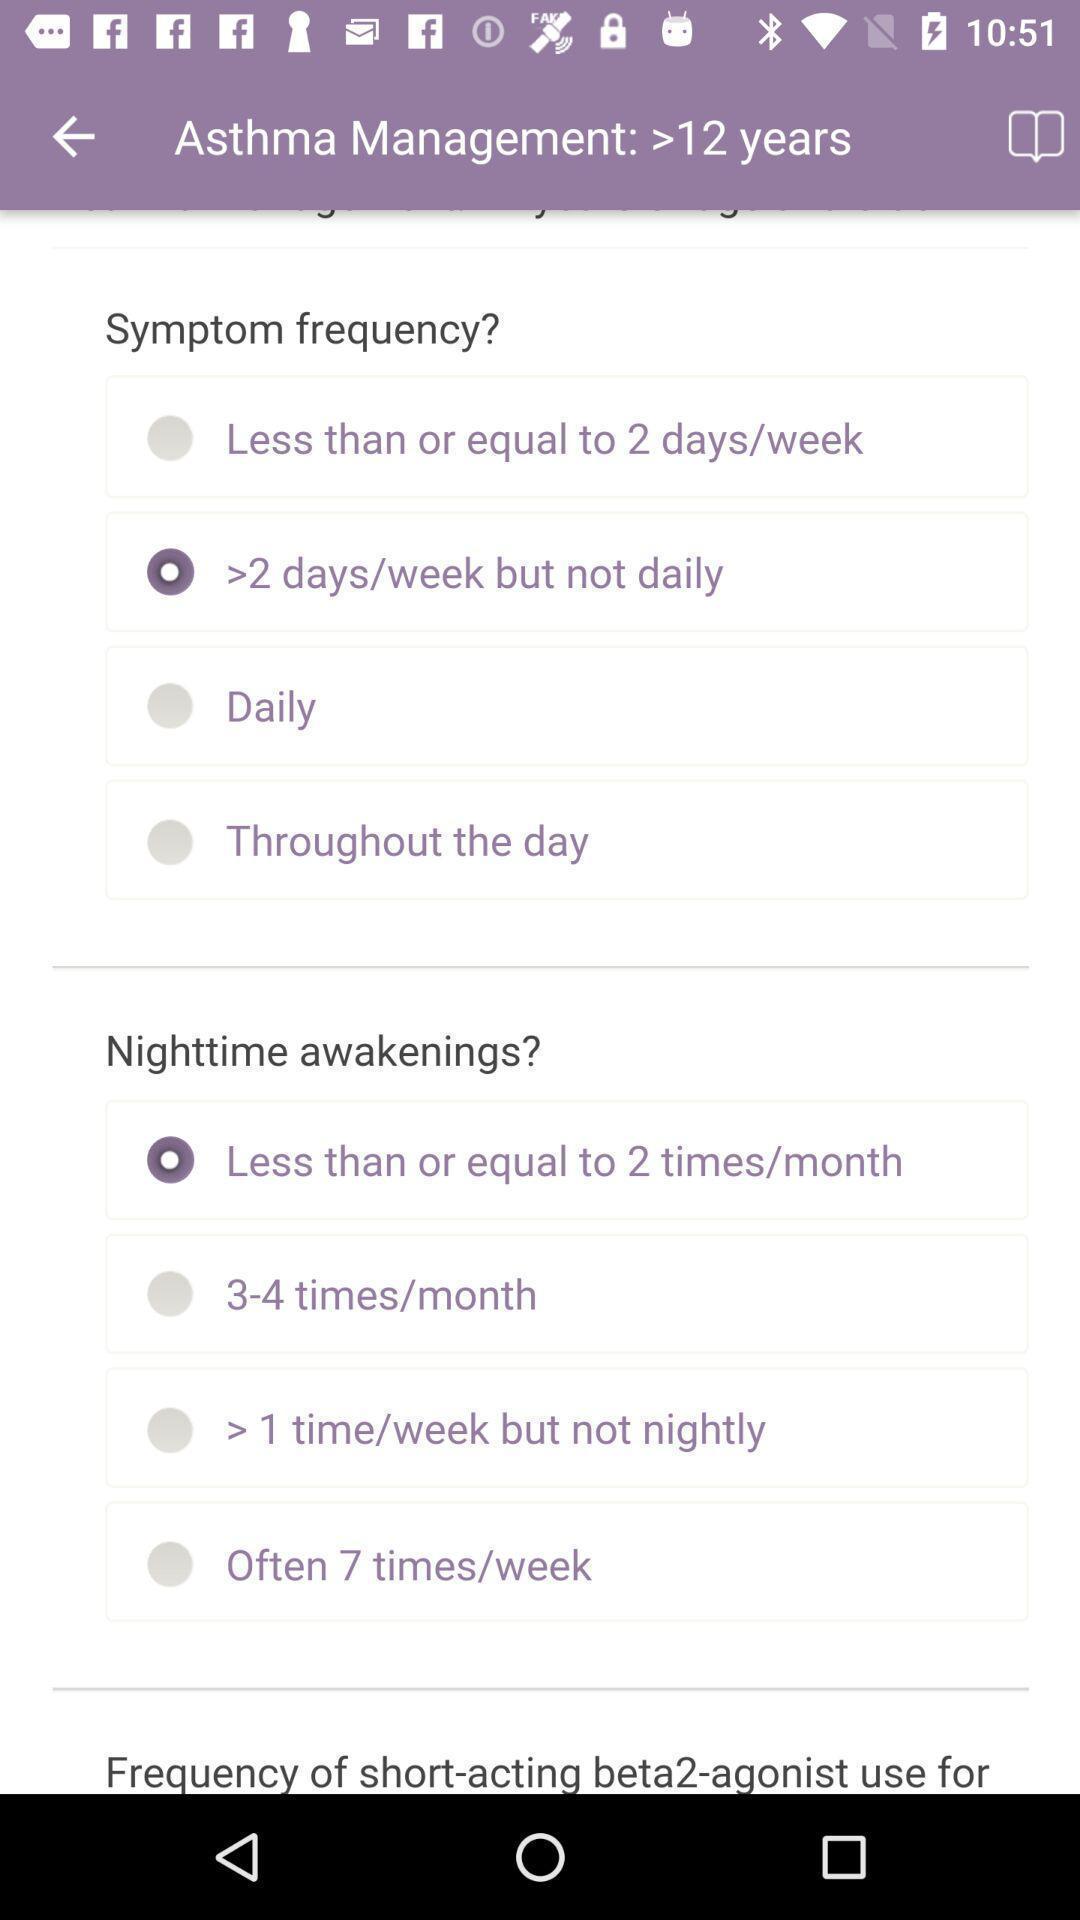Please provide a description for this image. Screen displaying the survey page. 